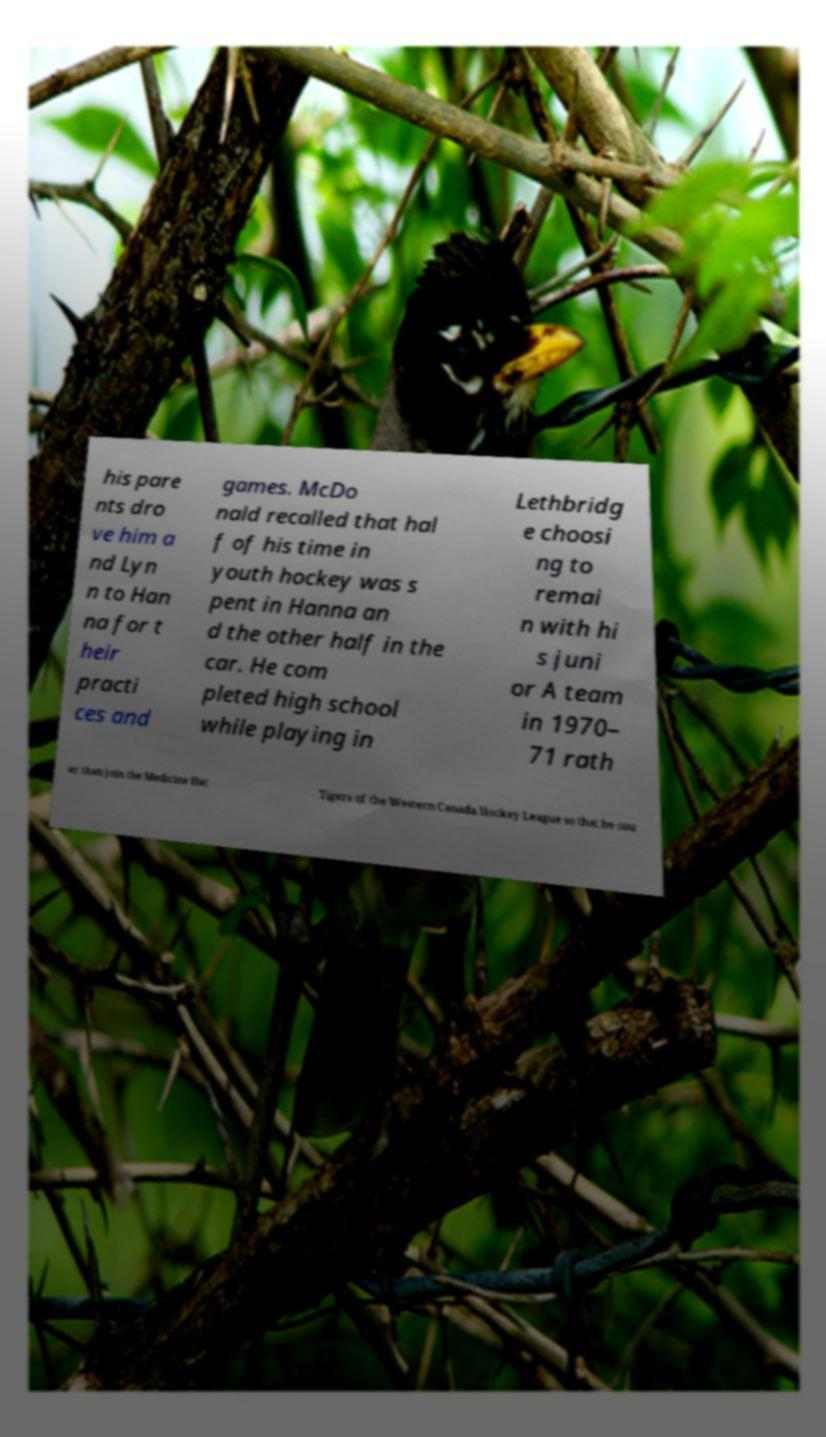Can you accurately transcribe the text from the provided image for me? his pare nts dro ve him a nd Lyn n to Han na for t heir practi ces and games. McDo nald recalled that hal f of his time in youth hockey was s pent in Hanna an d the other half in the car. He com pleted high school while playing in Lethbridg e choosi ng to remai n with hi s juni or A team in 1970– 71 rath er than join the Medicine Hat Tigers of the Western Canada Hockey League so that he cou 